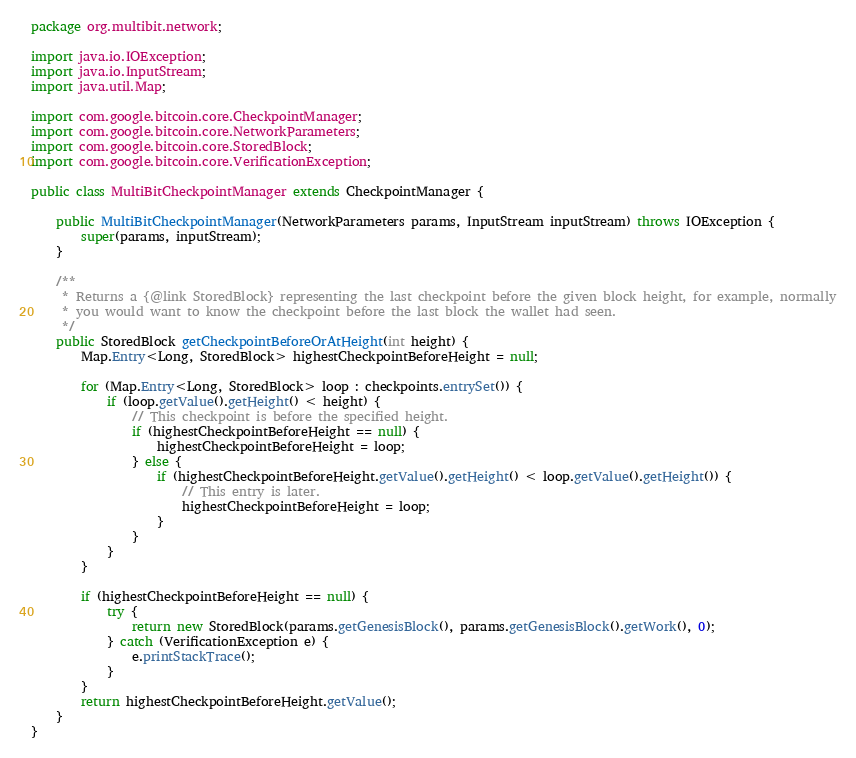<code> <loc_0><loc_0><loc_500><loc_500><_Java_>package org.multibit.network;

import java.io.IOException;
import java.io.InputStream;
import java.util.Map;

import com.google.bitcoin.core.CheckpointManager;
import com.google.bitcoin.core.NetworkParameters;
import com.google.bitcoin.core.StoredBlock;
import com.google.bitcoin.core.VerificationException;

public class MultiBitCheckpointManager extends CheckpointManager {

    public MultiBitCheckpointManager(NetworkParameters params, InputStream inputStream) throws IOException {
        super(params, inputStream);
    }
    
    /**
     * Returns a {@link StoredBlock} representing the last checkpoint before the given block height, for example, normally
     * you would want to know the checkpoint before the last block the wallet had seen.
     */
    public StoredBlock getCheckpointBeforeOrAtHeight(int height) {
        Map.Entry<Long, StoredBlock> highestCheckpointBeforeHeight = null;
        
        for (Map.Entry<Long, StoredBlock> loop : checkpoints.entrySet()) {
            if (loop.getValue().getHeight() < height) {
                // This checkpoint is before the specified height.
                if (highestCheckpointBeforeHeight == null) {
                    highestCheckpointBeforeHeight = loop;
                } else {
                    if (highestCheckpointBeforeHeight.getValue().getHeight() < loop.getValue().getHeight()) {
                        // This entry is later.
                        highestCheckpointBeforeHeight = loop;
                    }
                }
            }
        }
        
        if (highestCheckpointBeforeHeight == null) {
            try {
                return new StoredBlock(params.getGenesisBlock(), params.getGenesisBlock().getWork(), 0);
            } catch (VerificationException e) {
                e.printStackTrace();
            }
        }
        return highestCheckpointBeforeHeight.getValue();
    }
}</code> 